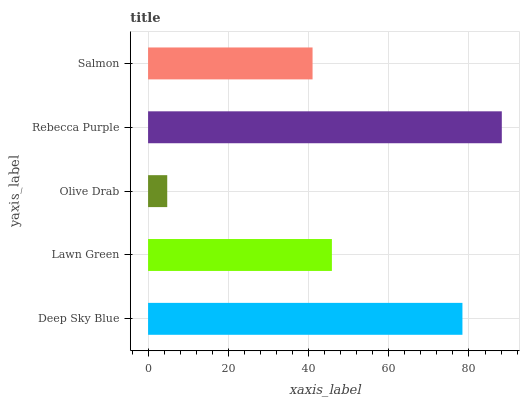Is Olive Drab the minimum?
Answer yes or no. Yes. Is Rebecca Purple the maximum?
Answer yes or no. Yes. Is Lawn Green the minimum?
Answer yes or no. No. Is Lawn Green the maximum?
Answer yes or no. No. Is Deep Sky Blue greater than Lawn Green?
Answer yes or no. Yes. Is Lawn Green less than Deep Sky Blue?
Answer yes or no. Yes. Is Lawn Green greater than Deep Sky Blue?
Answer yes or no. No. Is Deep Sky Blue less than Lawn Green?
Answer yes or no. No. Is Lawn Green the high median?
Answer yes or no. Yes. Is Lawn Green the low median?
Answer yes or no. Yes. Is Olive Drab the high median?
Answer yes or no. No. Is Rebecca Purple the low median?
Answer yes or no. No. 